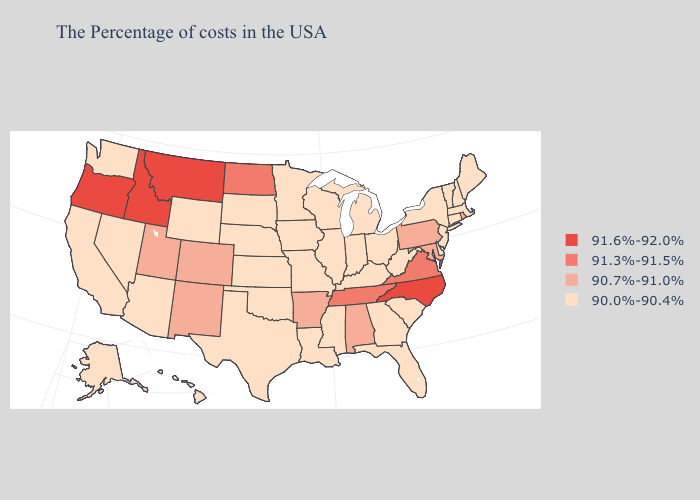Name the states that have a value in the range 91.6%-92.0%?
Keep it brief. North Carolina, Montana, Idaho, Oregon. Does the first symbol in the legend represent the smallest category?
Keep it brief. No. Does Texas have the highest value in the South?
Keep it brief. No. Does Delaware have a lower value than California?
Short answer required. No. How many symbols are there in the legend?
Short answer required. 4. What is the value of Maine?
Keep it brief. 90.0%-90.4%. What is the value of Ohio?
Give a very brief answer. 90.0%-90.4%. What is the lowest value in the MidWest?
Be succinct. 90.0%-90.4%. Which states have the lowest value in the USA?
Be succinct. Maine, Massachusetts, New Hampshire, Vermont, Connecticut, New York, New Jersey, Delaware, South Carolina, West Virginia, Ohio, Florida, Georgia, Michigan, Kentucky, Indiana, Wisconsin, Illinois, Mississippi, Louisiana, Missouri, Minnesota, Iowa, Kansas, Nebraska, Oklahoma, Texas, South Dakota, Wyoming, Arizona, Nevada, California, Washington, Alaska, Hawaii. Which states have the lowest value in the Northeast?
Give a very brief answer. Maine, Massachusetts, New Hampshire, Vermont, Connecticut, New York, New Jersey. Which states hav the highest value in the South?
Answer briefly. North Carolina. What is the highest value in states that border South Dakota?
Short answer required. 91.6%-92.0%. What is the lowest value in the USA?
Write a very short answer. 90.0%-90.4%. Does the map have missing data?
Answer briefly. No. 